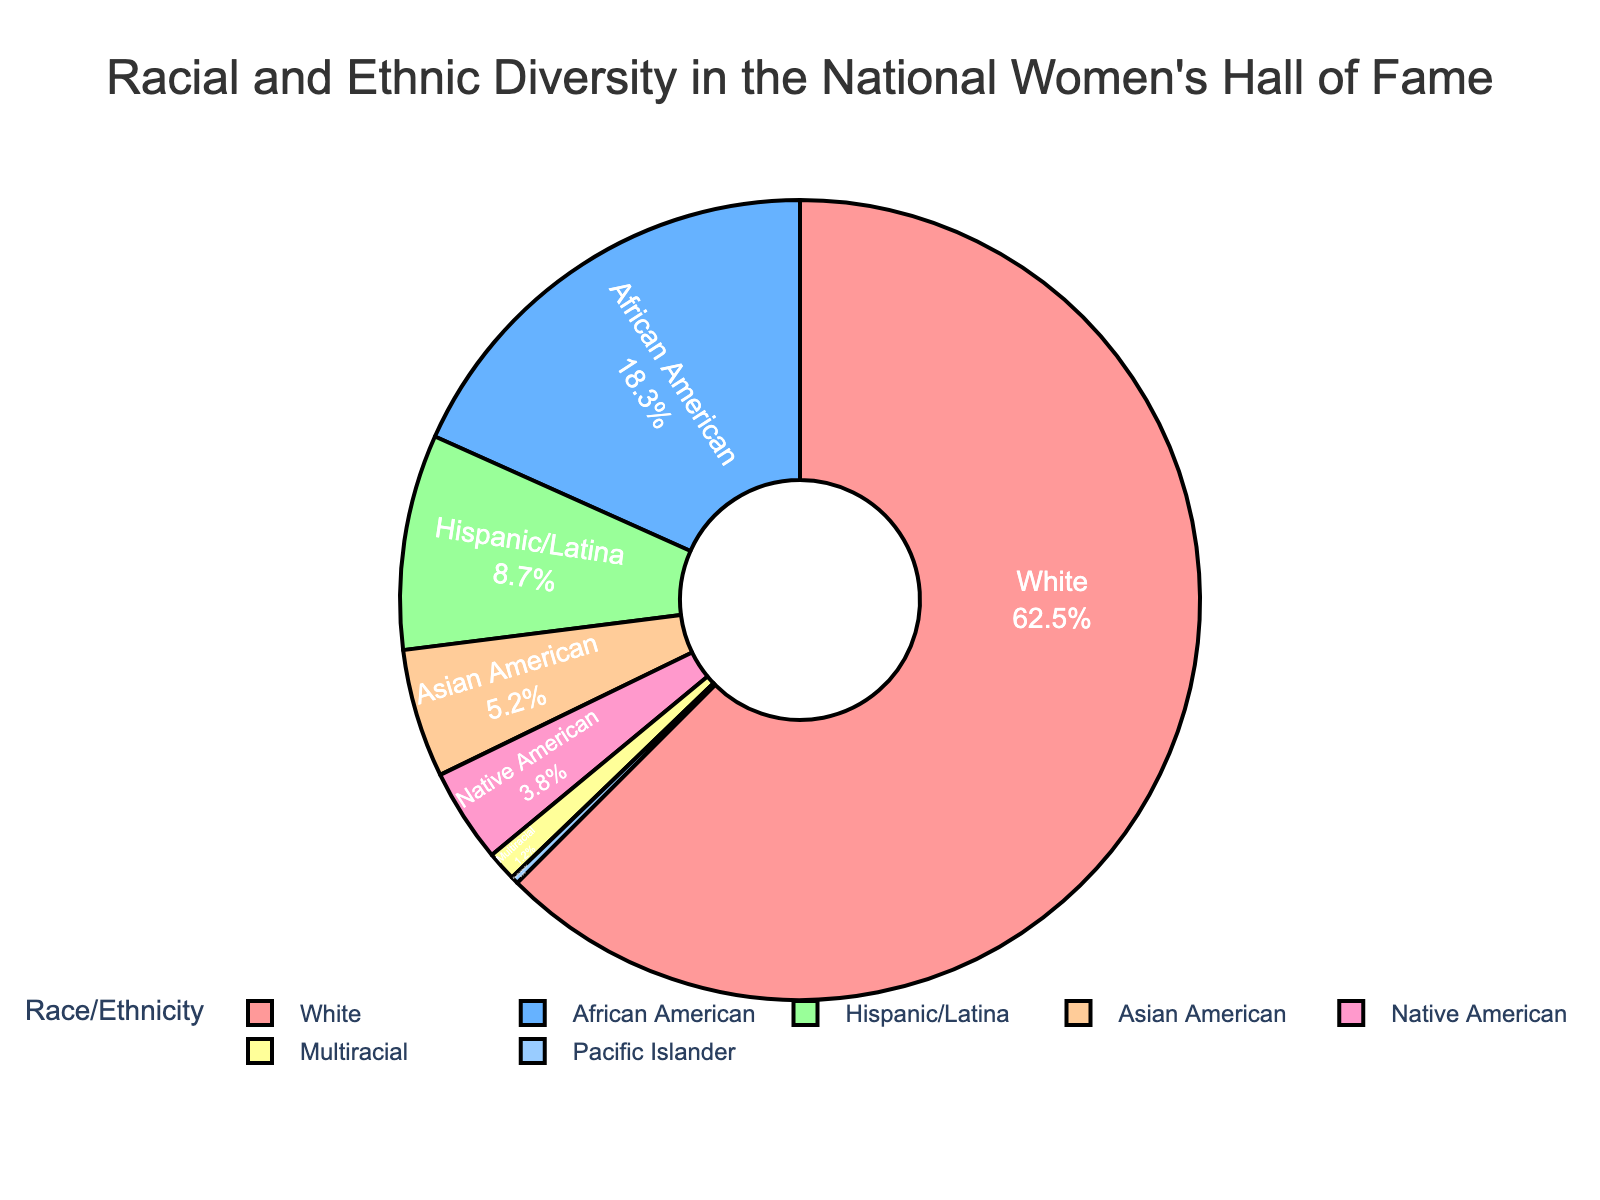Which race/ethnicity group has the highest percentage in the Hall of Fame? By observing the pie chart, the group with the largest segment will have the highest percentage. The largest segment is labeled "White" with 62.5%.
Answer: White What is the combined percentage of African American and Hispanic/Latina women honored in the Hall of Fame? First, locate the segments labeled "African American" and "Hispanic/Latina" in the pie chart. The percentages are 18.3% and 8.7%, respectively. Adding these together: 18.3 + 8.7 = 27.
Answer: 27 Which groups have a percentage lower than 5%? Identify the segments in the pie chart with percentages below 5%. The groups are "Asian American" (5.2% is not included as it is not lower than 5), "Native American" (3.8%), "Multiracial" (1.2%), and "Pacific Islander" (0.3%).
Answer: Native American, Multiracial, Pacific Islander What is the difference in percentage between the largest and smallest racial/ethnicity groups? The largest percentage is for "White" with 62.5%, and the smallest is for "Pacific Islander" with 0.3%. The difference is 62.5 - 0.3 = 62.2.
Answer: 62.2 What percentage of honorees identify as either Multiracial or Native American? Find the segments labeled "Multiracial" and "Native American." Their respective percentages are 1.2% and 3.8%. Adding these together gives 1.2 + 3.8 = 5.
Answer: 5 Is the percentage of Hispanic/Latina honorees greater or less than 10%? Locate the segment labeled "Hispanic/Latina" and identify its percentage, which is 8.7%. Compare this to 10%. Since 8.7% is less than 10%, the answer is less.
Answer: Less How many groups have a percentage greater than the average percentage of all groups? Calculate the average percentage by summing all percentages and dividing by the number of groups. Total sum = 62.5 + 18.3 + 8.7 + 5.2 + 3.8 + 1.2 + 0.3 = 100. Divide by 7 groups: 100/7 ≈ 14.29. The groups with percentages greater than 14.29% are "White" and "African American."
Answer: 2 What percentage of the honorees are either Asian American or Pacific Islander? Find the segments for "Asian American" and "Pacific Islander" which are 5.2% and 0.3%, respectively. Adding these together gives 5.2 + 0.3 = 5.5.
Answer: 5.5 Which racial/ethnic group has a percentage very close to the total percentage of Multiracial and Native American groups combined? Find the combined percentage of Multiracial (1.2%) and Native American (3.8%): 1.2 + 3.8 = 5%. The group with a percentage close to 5% is "Asian American" with 5.2%.
Answer: Asian American 